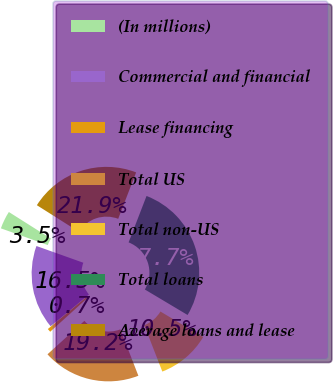Convert chart. <chart><loc_0><loc_0><loc_500><loc_500><pie_chart><fcel>(In millions)<fcel>Commercial and financial<fcel>Lease financing<fcel>Total US<fcel>Total non-US<fcel>Total loans<fcel>Average loans and lease<nl><fcel>3.52%<fcel>16.48%<fcel>0.69%<fcel>19.19%<fcel>10.53%<fcel>27.7%<fcel>21.89%<nl></chart> 